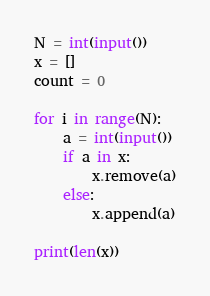<code> <loc_0><loc_0><loc_500><loc_500><_Python_>N = int(input())
x = []
count = 0

for i in range(N):
    a = int(input())
    if a in x:
        x.remove(a)
    else:
        x.append(a)

print(len(x))
</code> 